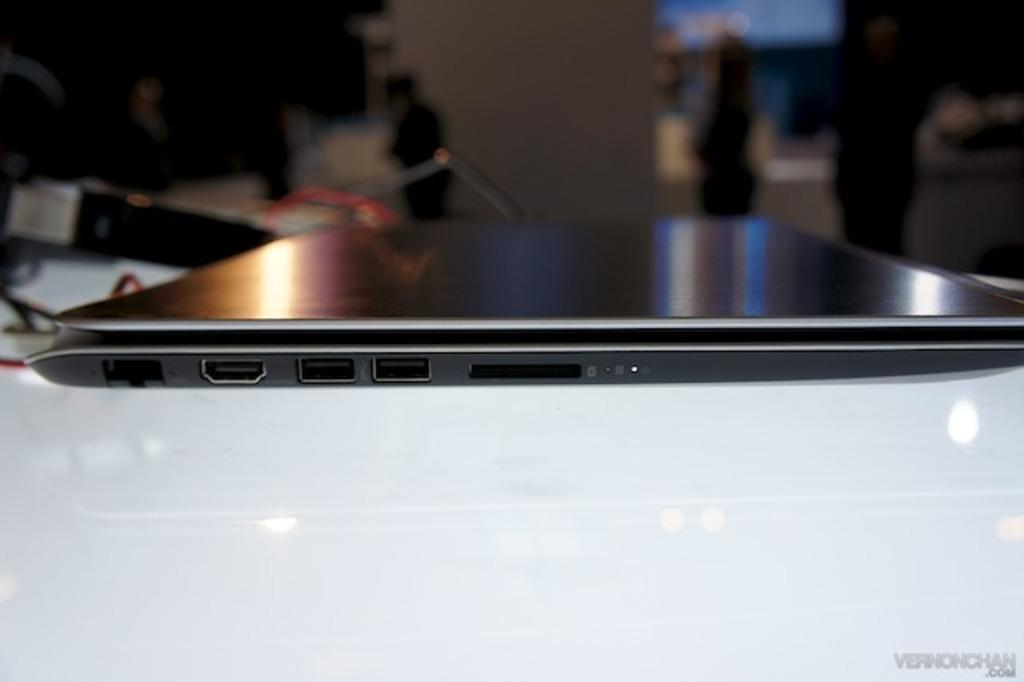What electronic device is visible in the image? There is a laptop in the image. On what surface is the laptop placed? The laptop is on a white surface. Can you describe the background of the image? The background of the image is blurred. How many gooses are visible on the hill in the image? There are no gooses or hills present in the image. What type of uniform is the fireman wearing in the image? There is no fireman present in the image. 